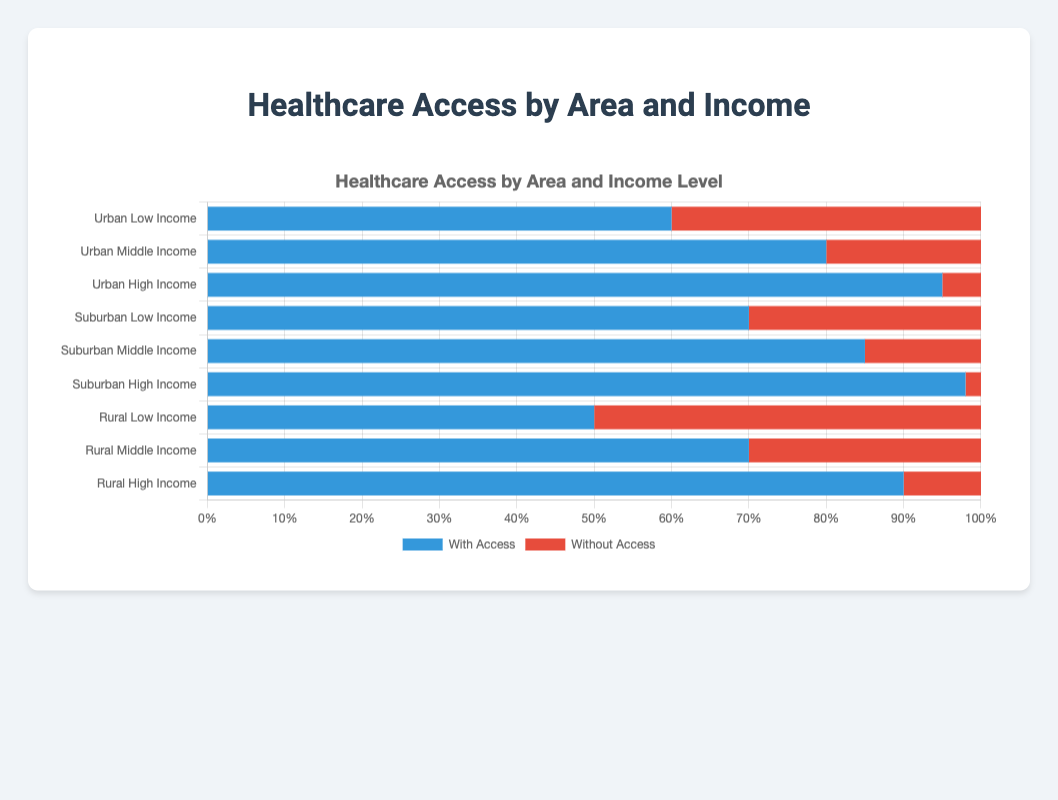What is the percentage of low-income individuals with healthcare access in urban areas? In the horizontal stacked bar chart, look at the section labeled 'Urban Low Income' and observe the portion colored in blue, which indicates the percentage with access.
Answer: 60% Do middle-income individuals in suburban areas have more access to healthcare compared to high-income individuals in rural areas? Compare the percentage with access for 'Suburban Middle Income' and 'Rural High Income' by looking at the respective blue sections of the bars. Suburban middle-income access is 85% and rural high-income access is 90%.
Answer: No Among urban, suburban, and rural areas, which group has the highest percentage of individuals without healthcare access? Examine the red portions of the bars across all income levels in the respective areas. The 'Rural Low Income' group has the highest percentage without access, at 50%.
Answer: Rural Low Income What is the difference in healthcare access between high-income individuals in urban areas and middle-income individuals in rural areas? Subtract the percentage with access for 'Rural Middle Income' (70%) from 'Urban High Income' (95%). 95% - 70% = 25%.
Answer: 25% What is the average percentage of healthcare access for middle-income individuals across all areas? Sum the percentages with access for middle-income individuals from urban (80%), suburban (85%), and rural (70%) areas, then divide by the number of areas. (80% + 85% + 70%)/3 = 78.33%
Answer: 78.33% Which income level in urban areas has the smallest percentage without healthcare access? Look at the red sections for 'Urban Low Income', 'Urban Middle Income', and 'Urban High Income', and find the smallest value. The high-income group has the smallest percentage without access at 5%.
Answer: Urban High Income What is the total percentage of suburban individuals (across all income levels) without healthcare access? Sum the percentages without access for low-income (30%), middle-income (15%), and high-income (2%) groups in suburban areas. 30% + 15% + 2% = 47%.
Answer: 47% How does the percentage of high-income individuals with healthcare access differ between suburban and rural areas? Compare the blue sections for 'Suburban High Income' (98%) and 'Rural High Income' (90%). The difference is 98% - 90% = 8%.
Answer: 8% What is the visual difference in the bar lengths for access between the lowest and highest income levels in rural areas? Visually inspect the blue sections of 'Rural Low Income' (50%) and 'Rural High Income' (90%). The blue bar for high-income is noticeably longer (40% more).
Answer: 40% Is healthcare access higher for low-income individuals in suburban areas compared to urban areas? Compare the blue sections for 'Suburban Low Income' (70%) and 'Urban Low Income' (60%). Suburban low-income individuals have higher access.
Answer: Yes 